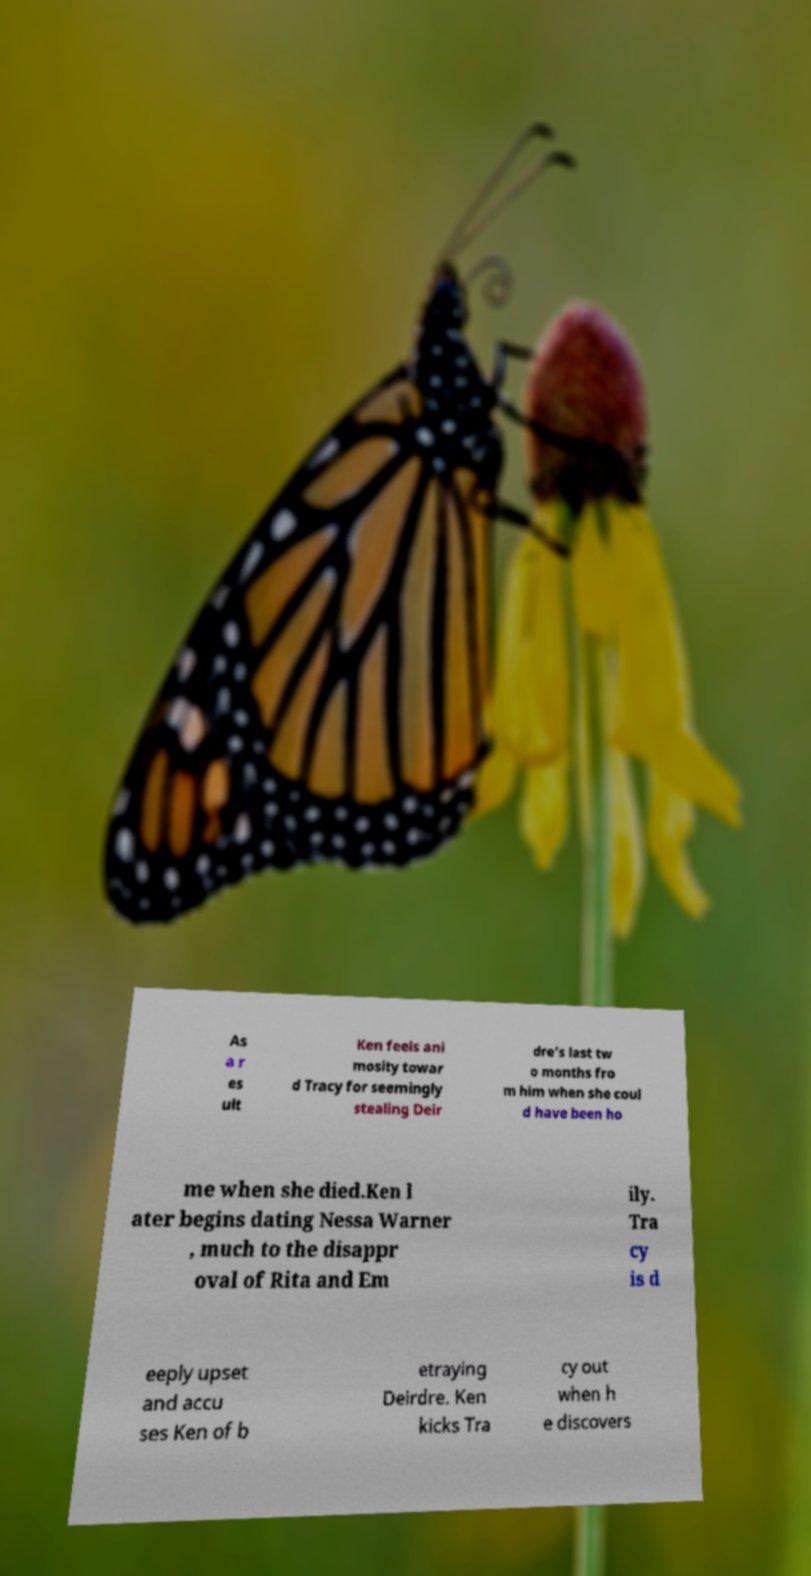Please identify and transcribe the text found in this image. As a r es ult Ken feels ani mosity towar d Tracy for seemingly stealing Deir dre's last tw o months fro m him when she coul d have been ho me when she died.Ken l ater begins dating Nessa Warner , much to the disappr oval of Rita and Em ily. Tra cy is d eeply upset and accu ses Ken of b etraying Deirdre. Ken kicks Tra cy out when h e discovers 